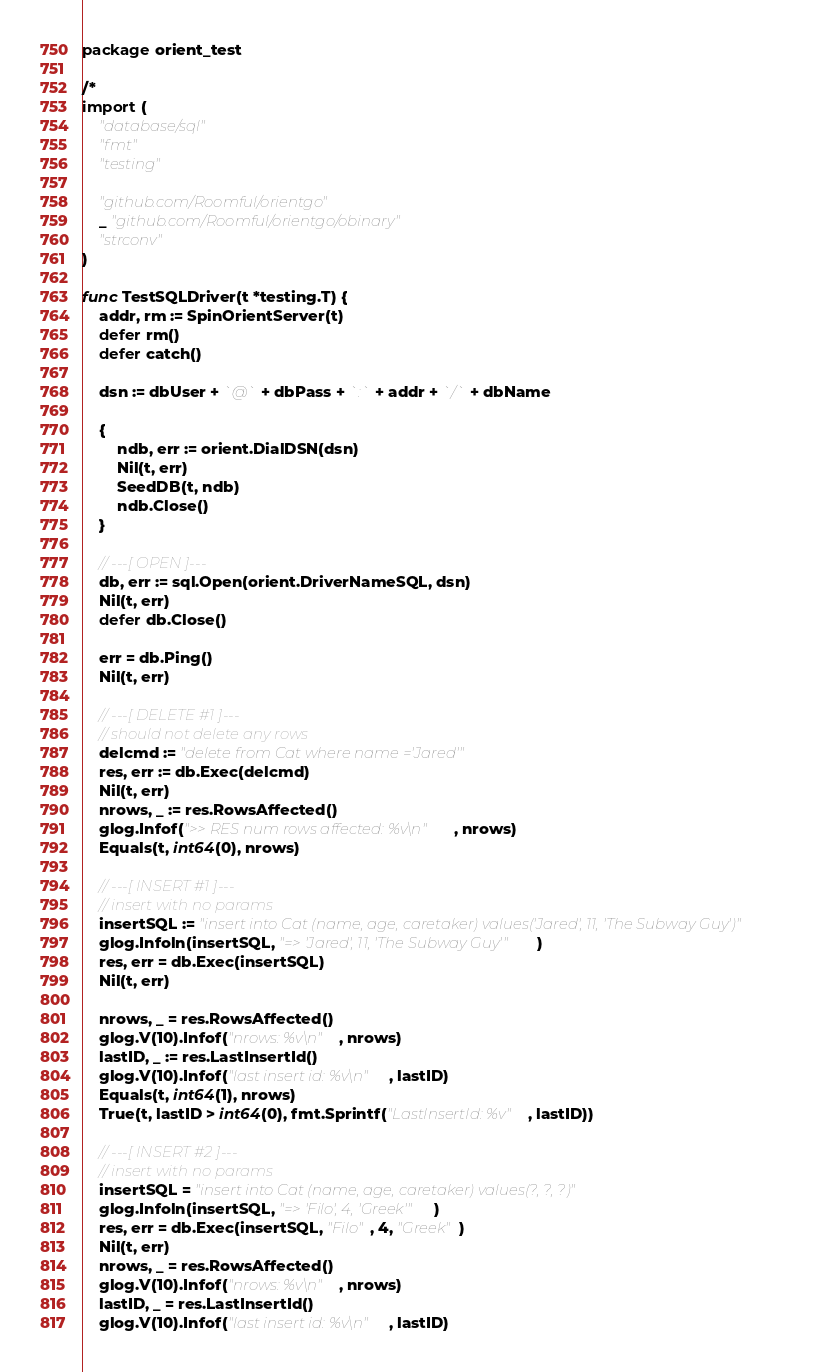<code> <loc_0><loc_0><loc_500><loc_500><_Go_>package orient_test

/*
import (
	"database/sql"
	"fmt"
	"testing"

	"github.com/Roomful/orientgo"
	_ "github.com/Roomful/orientgo/obinary"
	"strconv"
)

func TestSQLDriver(t *testing.T) {
	addr, rm := SpinOrientServer(t)
	defer rm()
	defer catch()

	dsn := dbUser + `@` + dbPass + `:` + addr + `/` + dbName

	{
		ndb, err := orient.DialDSN(dsn)
		Nil(t, err)
		SeedDB(t, ndb)
		ndb.Close()
	}

	// ---[ OPEN ]---
	db, err := sql.Open(orient.DriverNameSQL, dsn)
	Nil(t, err)
	defer db.Close()

	err = db.Ping()
	Nil(t, err)

	// ---[ DELETE #1 ]---
	// should not delete any rows
	delcmd := "delete from Cat where name ='Jared'"
	res, err := db.Exec(delcmd)
	Nil(t, err)
	nrows, _ := res.RowsAffected()
	glog.Infof(">> RES num rows affected: %v\n", nrows)
	Equals(t, int64(0), nrows)

	// ---[ INSERT #1 ]---
	// insert with no params
	insertSQL := "insert into Cat (name, age, caretaker) values('Jared', 11, 'The Subway Guy')"
	glog.Infoln(insertSQL, "=> 'Jared', 11, 'The Subway Guy'")
	res, err = db.Exec(insertSQL)
	Nil(t, err)

	nrows, _ = res.RowsAffected()
	glog.V(10).Infof("nrows: %v\n", nrows)
	lastID, _ := res.LastInsertId()
	glog.V(10).Infof("last insert id: %v\n", lastID)
	Equals(t, int64(1), nrows)
	True(t, lastID > int64(0), fmt.Sprintf("LastInsertId: %v", lastID))

	// ---[ INSERT #2 ]---
	// insert with no params
	insertSQL = "insert into Cat (name, age, caretaker) values(?, ?, ?)"
	glog.Infoln(insertSQL, "=> 'Filo', 4, 'Greek'")
	res, err = db.Exec(insertSQL, "Filo", 4, "Greek")
	Nil(t, err)
	nrows, _ = res.RowsAffected()
	glog.V(10).Infof("nrows: %v\n", nrows)
	lastID, _ = res.LastInsertId()
	glog.V(10).Infof("last insert id: %v\n", lastID)</code> 